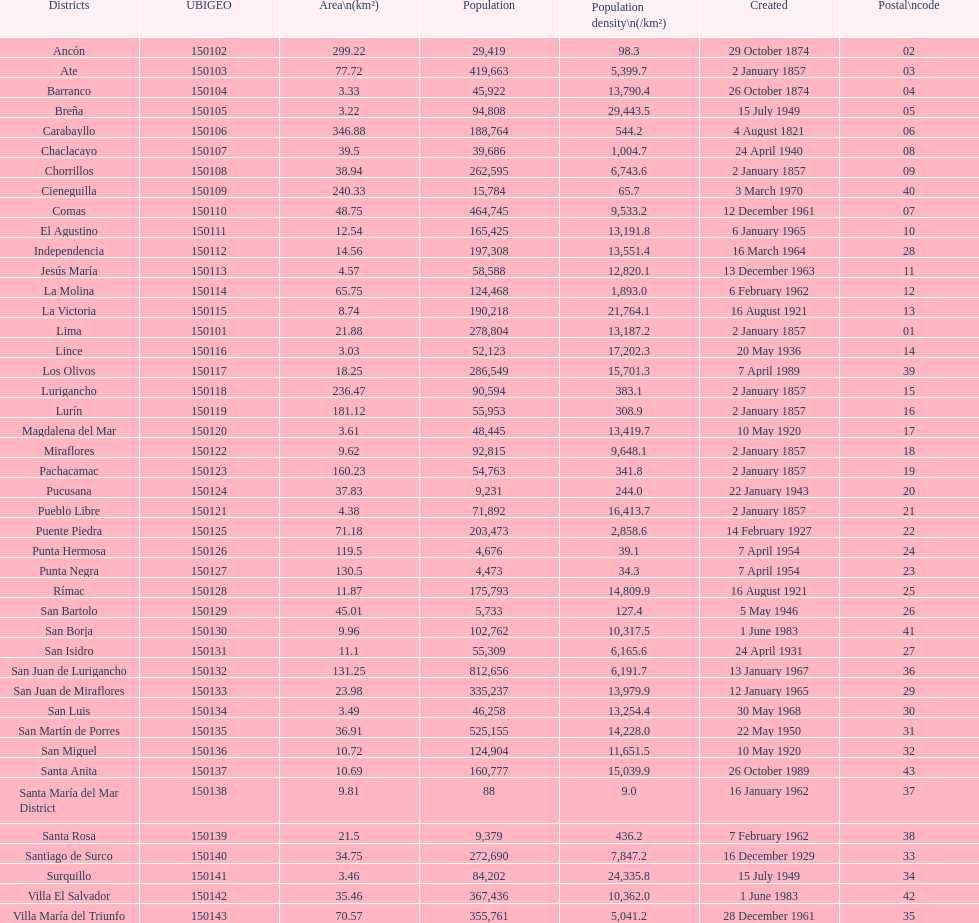When was the final district established? Santa Anita. Can you parse all the data within this table? {'header': ['Districts', 'UBIGEO', 'Area\\n(km²)', 'Population', 'Population density\\n(/km²)', 'Created', 'Postal\\ncode'], 'rows': [['Ancón', '150102', '299.22', '29,419', '98.3', '29 October 1874', '02'], ['Ate', '150103', '77.72', '419,663', '5,399.7', '2 January 1857', '03'], ['Barranco', '150104', '3.33', '45,922', '13,790.4', '26 October 1874', '04'], ['Breña', '150105', '3.22', '94,808', '29,443.5', '15 July 1949', '05'], ['Carabayllo', '150106', '346.88', '188,764', '544.2', '4 August 1821', '06'], ['Chaclacayo', '150107', '39.5', '39,686', '1,004.7', '24 April 1940', '08'], ['Chorrillos', '150108', '38.94', '262,595', '6,743.6', '2 January 1857', '09'], ['Cieneguilla', '150109', '240.33', '15,784', '65.7', '3 March 1970', '40'], ['Comas', '150110', '48.75', '464,745', '9,533.2', '12 December 1961', '07'], ['El Agustino', '150111', '12.54', '165,425', '13,191.8', '6 January 1965', '10'], ['Independencia', '150112', '14.56', '197,308', '13,551.4', '16 March 1964', '28'], ['Jesús María', '150113', '4.57', '58,588', '12,820.1', '13 December 1963', '11'], ['La Molina', '150114', '65.75', '124,468', '1,893.0', '6 February 1962', '12'], ['La Victoria', '150115', '8.74', '190,218', '21,764.1', '16 August 1921', '13'], ['Lima', '150101', '21.88', '278,804', '13,187.2', '2 January 1857', '01'], ['Lince', '150116', '3.03', '52,123', '17,202.3', '20 May 1936', '14'], ['Los Olivos', '150117', '18.25', '286,549', '15,701.3', '7 April 1989', '39'], ['Lurigancho', '150118', '236.47', '90,594', '383.1', '2 January 1857', '15'], ['Lurín', '150119', '181.12', '55,953', '308.9', '2 January 1857', '16'], ['Magdalena del Mar', '150120', '3.61', '48,445', '13,419.7', '10 May 1920', '17'], ['Miraflores', '150122', '9.62', '92,815', '9,648.1', '2 January 1857', '18'], ['Pachacamac', '150123', '160.23', '54,763', '341.8', '2 January 1857', '19'], ['Pucusana', '150124', '37.83', '9,231', '244.0', '22 January 1943', '20'], ['Pueblo Libre', '150121', '4.38', '71,892', '16,413.7', '2 January 1857', '21'], ['Puente Piedra', '150125', '71.18', '203,473', '2,858.6', '14 February 1927', '22'], ['Punta Hermosa', '150126', '119.5', '4,676', '39.1', '7 April 1954', '24'], ['Punta Negra', '150127', '130.5', '4,473', '34.3', '7 April 1954', '23'], ['Rímac', '150128', '11.87', '175,793', '14,809.9', '16 August 1921', '25'], ['San Bartolo', '150129', '45.01', '5,733', '127.4', '5 May 1946', '26'], ['San Borja', '150130', '9.96', '102,762', '10,317.5', '1 June 1983', '41'], ['San Isidro', '150131', '11.1', '55,309', '6,165.6', '24 April 1931', '27'], ['San Juan de Lurigancho', '150132', '131.25', '812,656', '6,191.7', '13 January 1967', '36'], ['San Juan de Miraflores', '150133', '23.98', '335,237', '13,979.9', '12 January 1965', '29'], ['San Luis', '150134', '3.49', '46,258', '13,254.4', '30 May 1968', '30'], ['San Martín de Porres', '150135', '36.91', '525,155', '14,228.0', '22 May 1950', '31'], ['San Miguel', '150136', '10.72', '124,904', '11,651.5', '10 May 1920', '32'], ['Santa Anita', '150137', '10.69', '160,777', '15,039.9', '26 October 1989', '43'], ['Santa María del Mar District', '150138', '9.81', '88', '9.0', '16 January 1962', '37'], ['Santa Rosa', '150139', '21.5', '9,379', '436.2', '7 February 1962', '38'], ['Santiago de Surco', '150140', '34.75', '272,690', '7,847.2', '16 December 1929', '33'], ['Surquillo', '150141', '3.46', '84,202', '24,335.8', '15 July 1949', '34'], ['Villa El Salvador', '150142', '35.46', '367,436', '10,362.0', '1 June 1983', '42'], ['Villa María del Triunfo', '150143', '70.57', '355,761', '5,041.2', '28 December 1961', '35']]} 